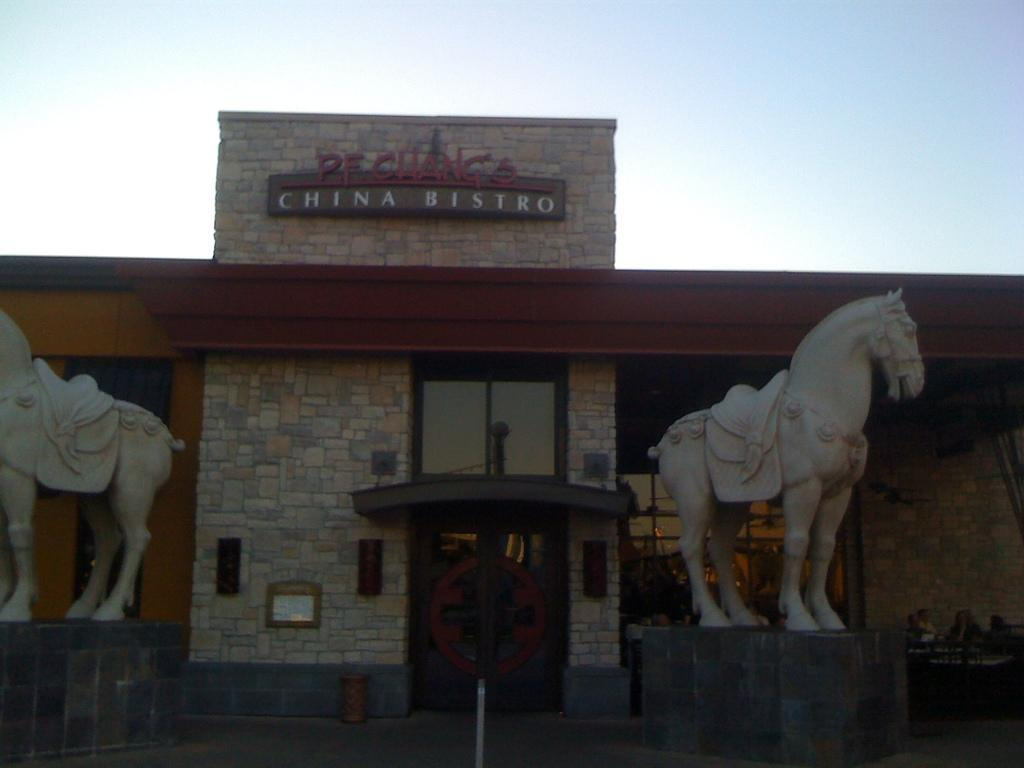What is the main subject in the center of the image? There is a building in the center of the image. What other elements can be seen in the image? There are depictions of horses in the image. What is visible at the top of the image? The sky is visible at the top of the image. How many umbrellas are being held by the horses in the image? There are no umbrellas present in the image, and the horses are not holding any objects. 